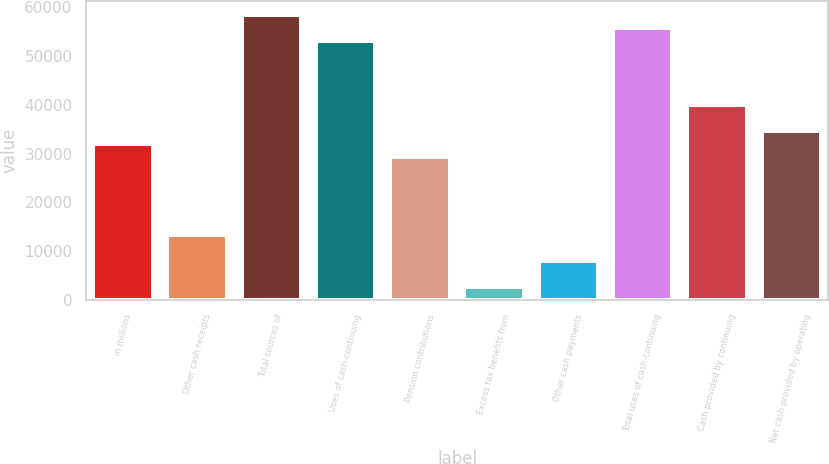Convert chart. <chart><loc_0><loc_0><loc_500><loc_500><bar_chart><fcel>in millions<fcel>Other cash receipts<fcel>Total sources of<fcel>Uses of cash-continuing<fcel>Pension contributions<fcel>Excess tax benefits from<fcel>Other cash payments<fcel>Total uses of cash-continuing<fcel>Cash provided by continuing<fcel>Net cash provided by operating<nl><fcel>31894.8<fcel>13293<fcel>58468.8<fcel>53154<fcel>29237.4<fcel>2663.4<fcel>7978.2<fcel>55811.4<fcel>39867<fcel>34552.2<nl></chart> 